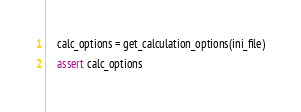<code> <loc_0><loc_0><loc_500><loc_500><_Python_>
    calc_options = get_calculation_options(ini_file)
    assert calc_options
</code> 